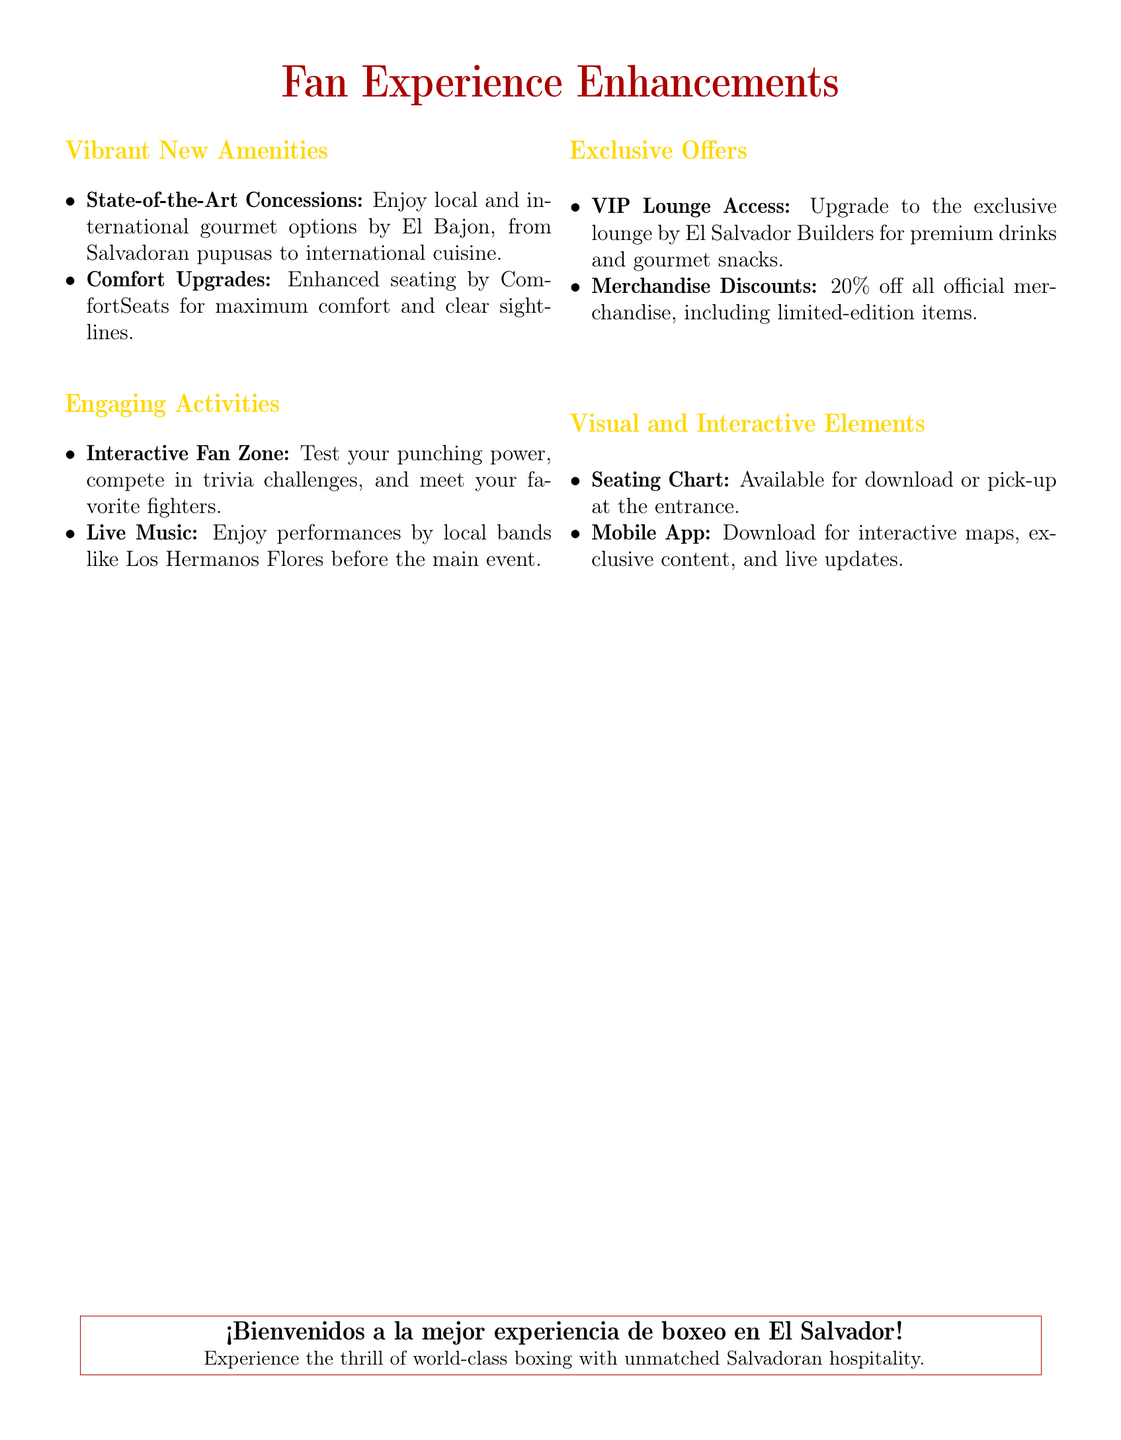what is the name of the gourmet option provided? The document mentions local and international gourmet options by El Bajon, specifically highlighting Salvadoran pupusas.
Answer: El Bajon what entertainment will be available before the main event? The document states that local bands like Los Hermanos Flores will perform before the main event.
Answer: Los Hermanos Flores what percentage discount is offered on official merchandise? The document mentions a specific discount on all official merchandise.
Answer: 20% what is included in the VIP Lounge Access? The document describes the VIP Lounge Access as providing premium drinks and gourmet snacks.
Answer: Premium drinks and gourmet snacks what type of seating upgrade is provided? The document notes that seating has been enhanced by ComfortSeats for better comfort.
Answer: ComfortSeats 